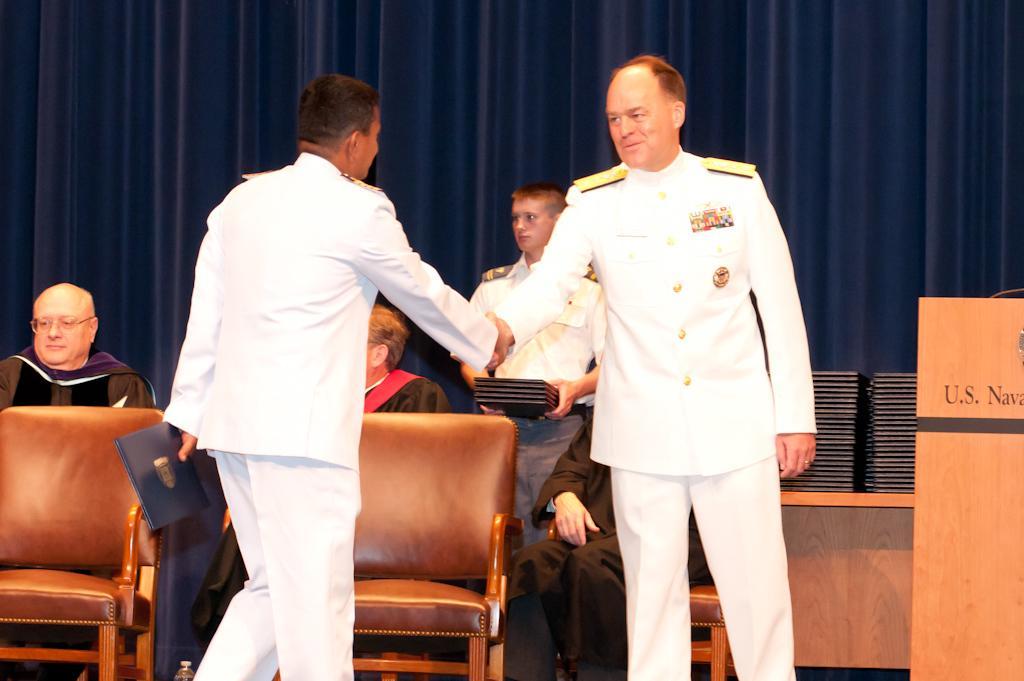In one or two sentences, can you explain what this image depicts? In front of the picture, we see two men in the uniform are standing and they are shaking their hands. Both of them are smiling. The man on the left side is holding a book in his hand. Beside them, we see the chairs. Behind that, we see three people are sitting on the chairs. Behind them, we see a man in the uniform is standing and he is holding the books in his hands. On the right side, we see a podium. Behind that, we see a table on which many books are placed. In the background, we see a sheet or the curtain in blue color. 